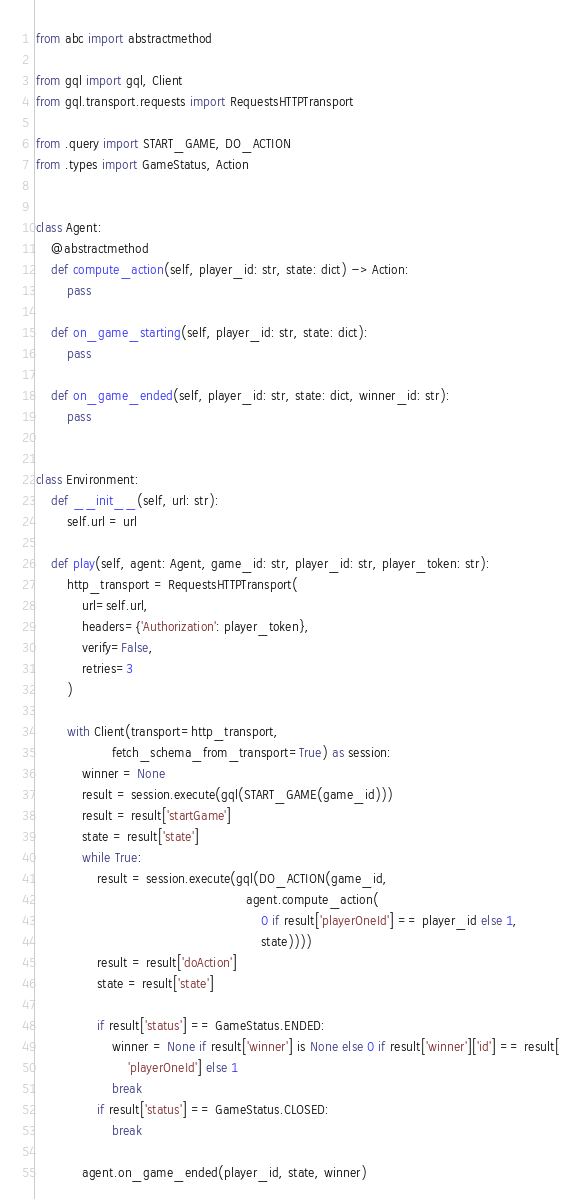<code> <loc_0><loc_0><loc_500><loc_500><_Python_>from abc import abstractmethod

from gql import gql, Client
from gql.transport.requests import RequestsHTTPTransport

from .query import START_GAME, DO_ACTION
from .types import GameStatus, Action


class Agent:
    @abstractmethod
    def compute_action(self, player_id: str, state: dict) -> Action:
        pass

    def on_game_starting(self, player_id: str, state: dict):
        pass

    def on_game_ended(self, player_id: str, state: dict, winner_id: str):
        pass


class Environment:
    def __init__(self, url: str):
        self.url = url

    def play(self, agent: Agent, game_id: str, player_id: str, player_token: str):
        http_transport = RequestsHTTPTransport(
            url=self.url,
            headers={'Authorization': player_token},
            verify=False,
            retries=3
        )

        with Client(transport=http_transport,
                    fetch_schema_from_transport=True) as session:
            winner = None
            result = session.execute(gql(START_GAME(game_id)))
            result = result['startGame']
            state = result['state']
            while True:
                result = session.execute(gql(DO_ACTION(game_id,
                                                       agent.compute_action(
                                                           0 if result['playerOneId'] == player_id else 1,
                                                           state))))
                result = result['doAction']
                state = result['state']

                if result['status'] == GameStatus.ENDED:
                    winner = None if result['winner'] is None else 0 if result['winner']['id'] == result[
                        'playerOneId'] else 1
                    break
                if result['status'] == GameStatus.CLOSED:
                    break

            agent.on_game_ended(player_id, state, winner)
</code> 